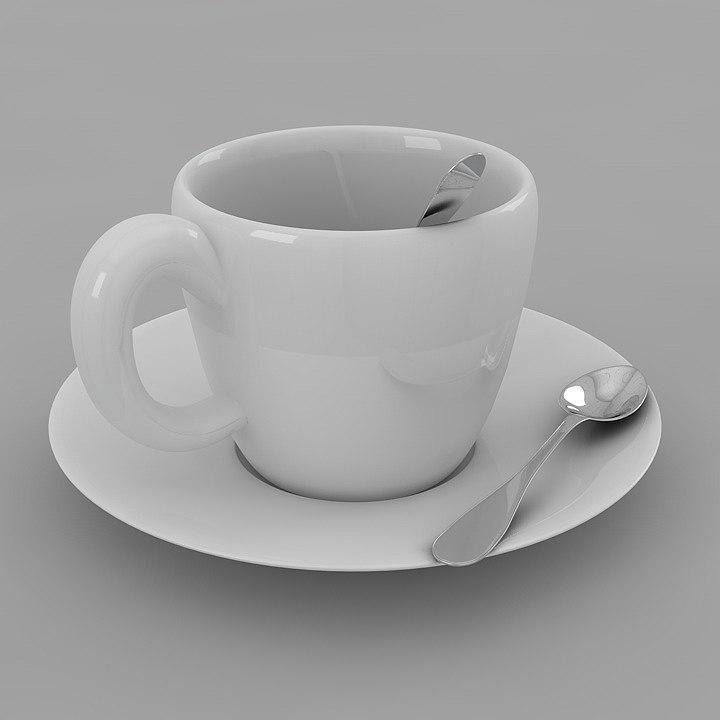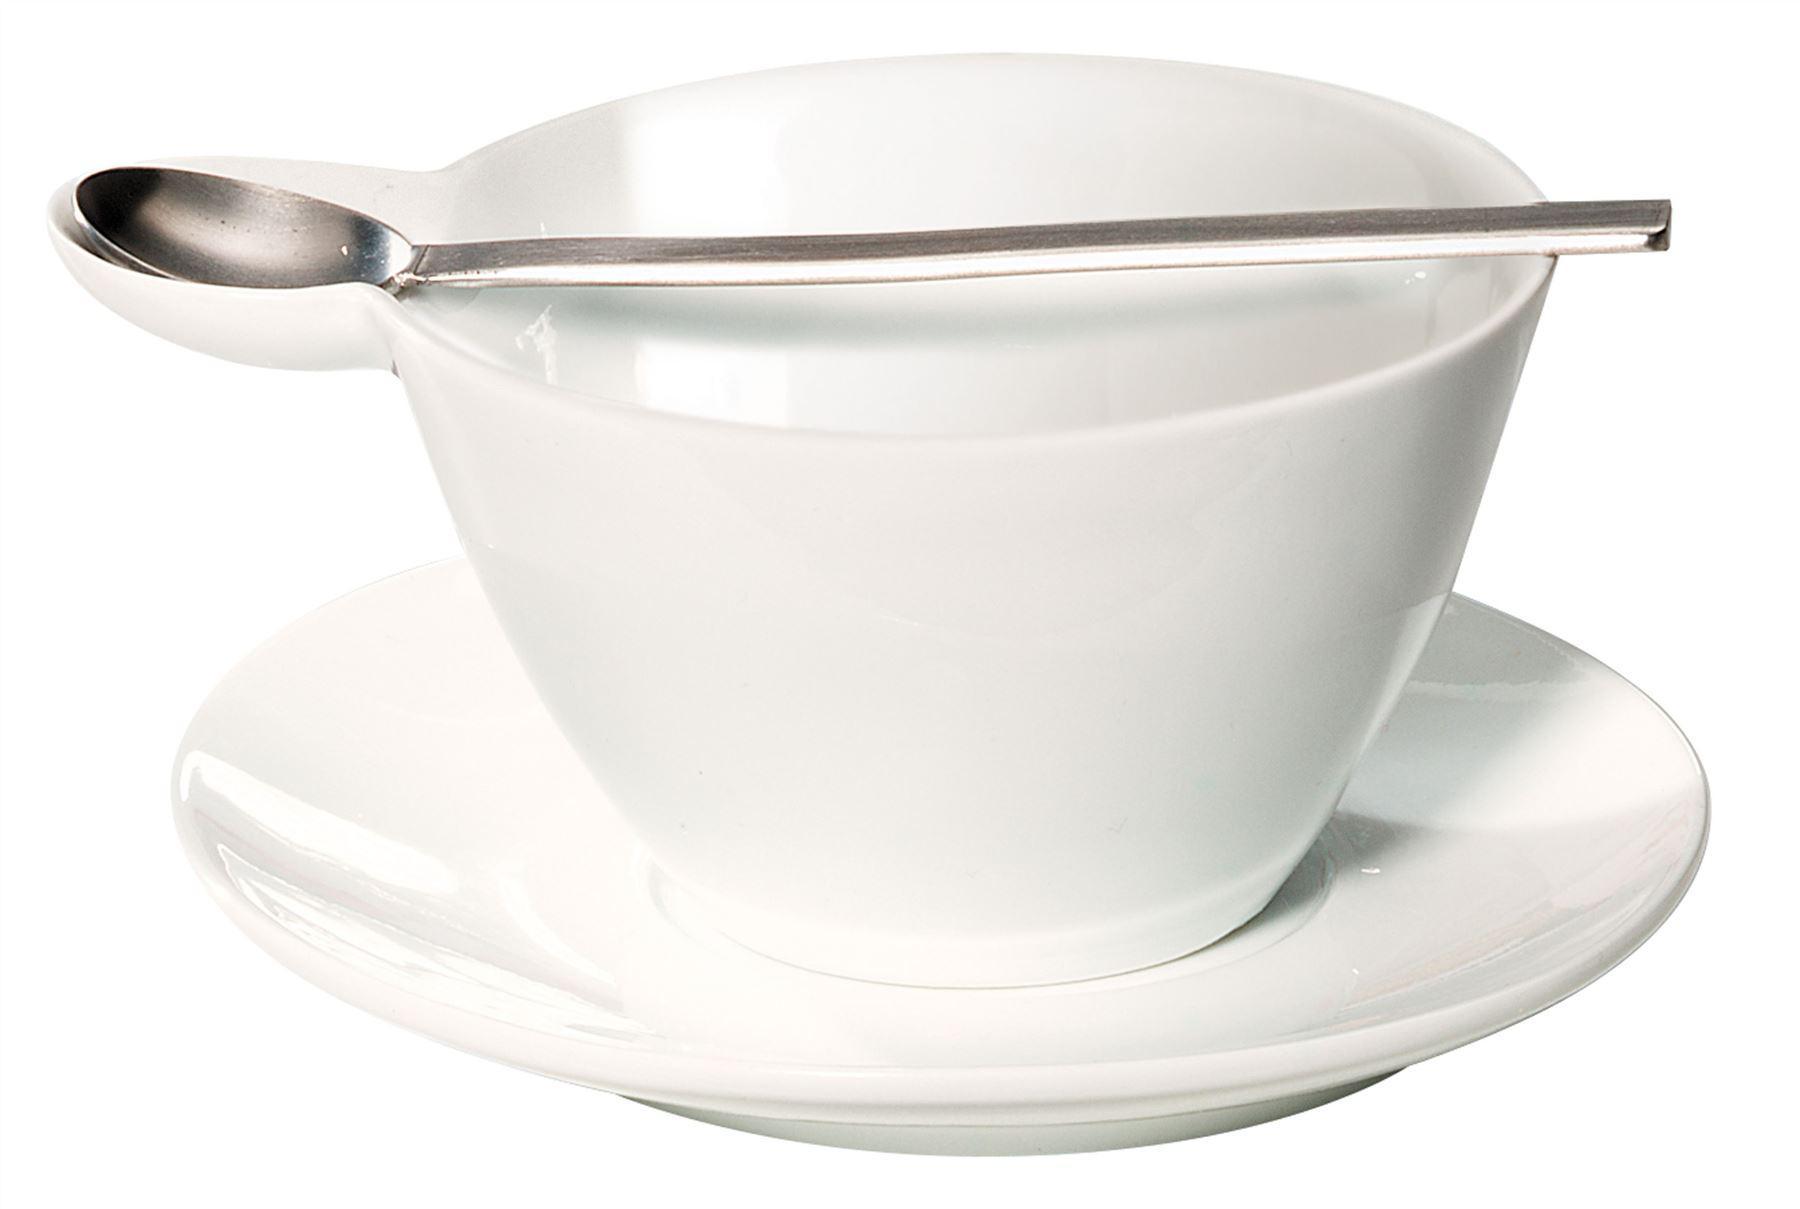The first image is the image on the left, the second image is the image on the right. Evaluate the accuracy of this statement regarding the images: "In each image there is a spoon laid next to the cup on the plate.". Is it true? Answer yes or no. No. The first image is the image on the left, the second image is the image on the right. For the images shown, is this caption "Both cups have a spoon sitting on their saucer." true? Answer yes or no. No. 